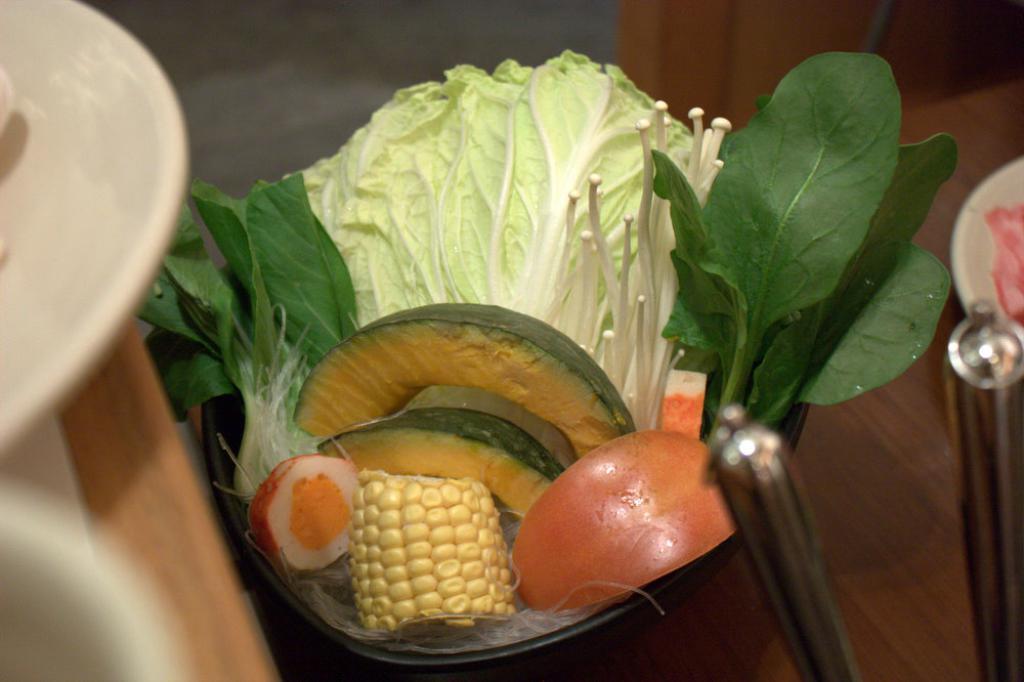Describe this image in one or two sentences. In this image, we can see some food items and white colored containers on the surface. We can also see some objects. We can see the ground. 